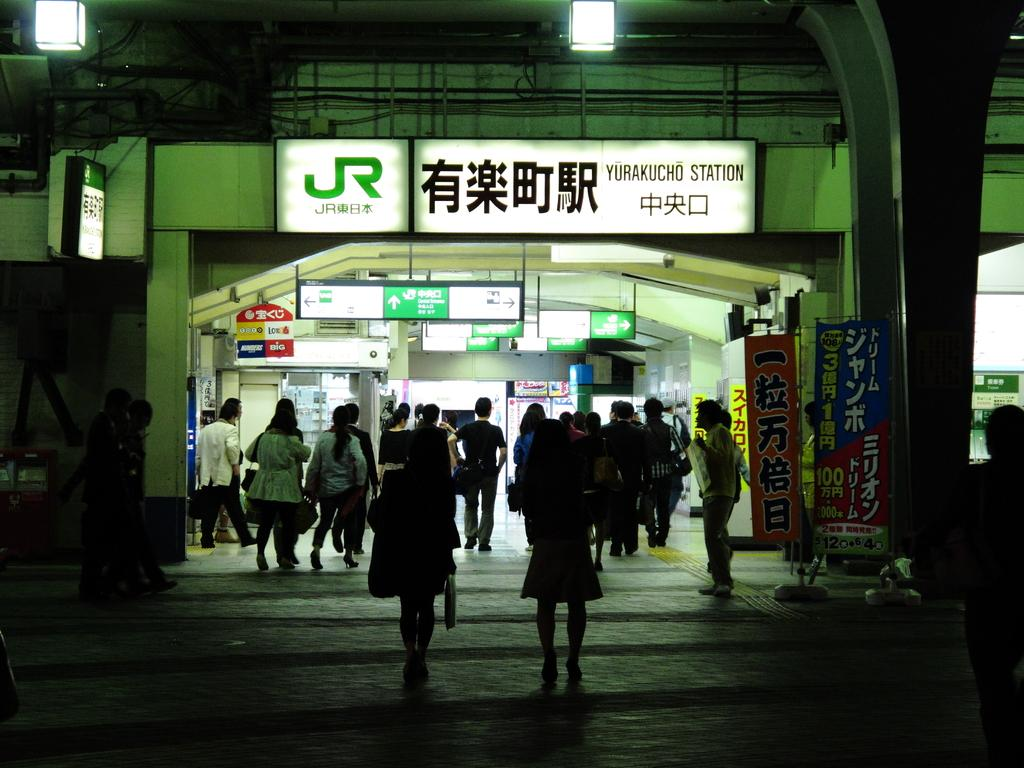<image>
Create a compact narrative representing the image presented. A far shot of the Yurakucho Station taken at night 